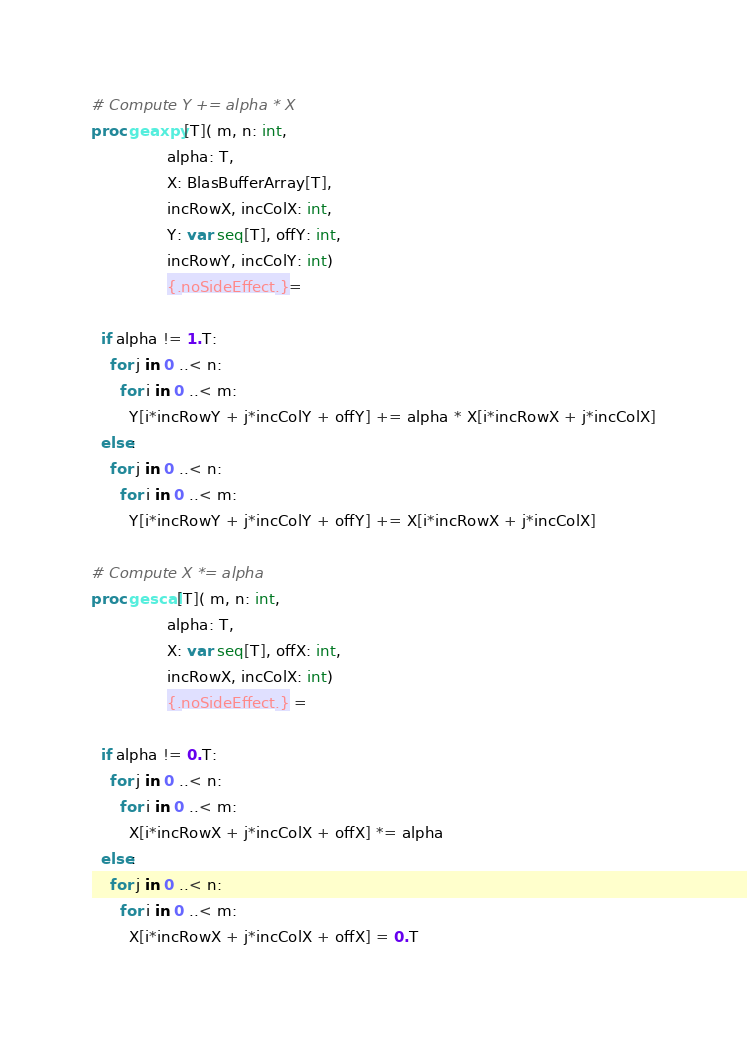Convert code to text. <code><loc_0><loc_0><loc_500><loc_500><_Nim_># Compute Y += alpha * X
proc geaxpy[T]( m, n: int,
                alpha: T,
                X: BlasBufferArray[T],
                incRowX, incColX: int,
                Y: var seq[T], offY: int,
                incRowY, incColY: int)
                {.noSideEffect.}=

  if alpha != 1.T:
    for j in 0 ..< n:
      for i in 0 ..< m:
        Y[i*incRowY + j*incColY + offY] += alpha * X[i*incRowX + j*incColX]
  else:
    for j in 0 ..< n:
      for i in 0 ..< m:
        Y[i*incRowY + j*incColY + offY] += X[i*incRowX + j*incColX]

# Compute X *= alpha
proc gescal[T]( m, n: int,
                alpha: T,
                X: var seq[T], offX: int,
                incRowX, incColX: int)
                {.noSideEffect.} =

  if alpha != 0.T:
    for j in 0 ..< n:
      for i in 0 ..< m:
        X[i*incRowX + j*incColX + offX] *= alpha
  else:
    for j in 0 ..< n:
      for i in 0 ..< m:
        X[i*incRowX + j*incColX + offX] = 0.T</code> 